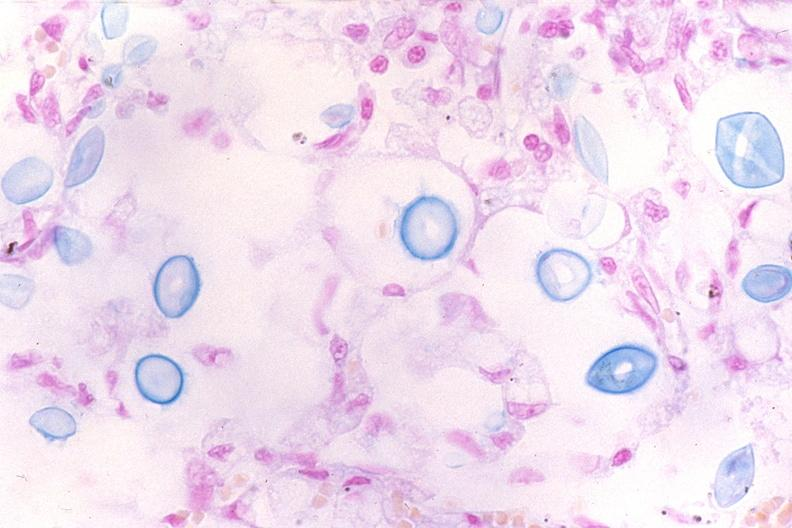s gangrene toe in infant present?
Answer the question using a single word or phrase. No 